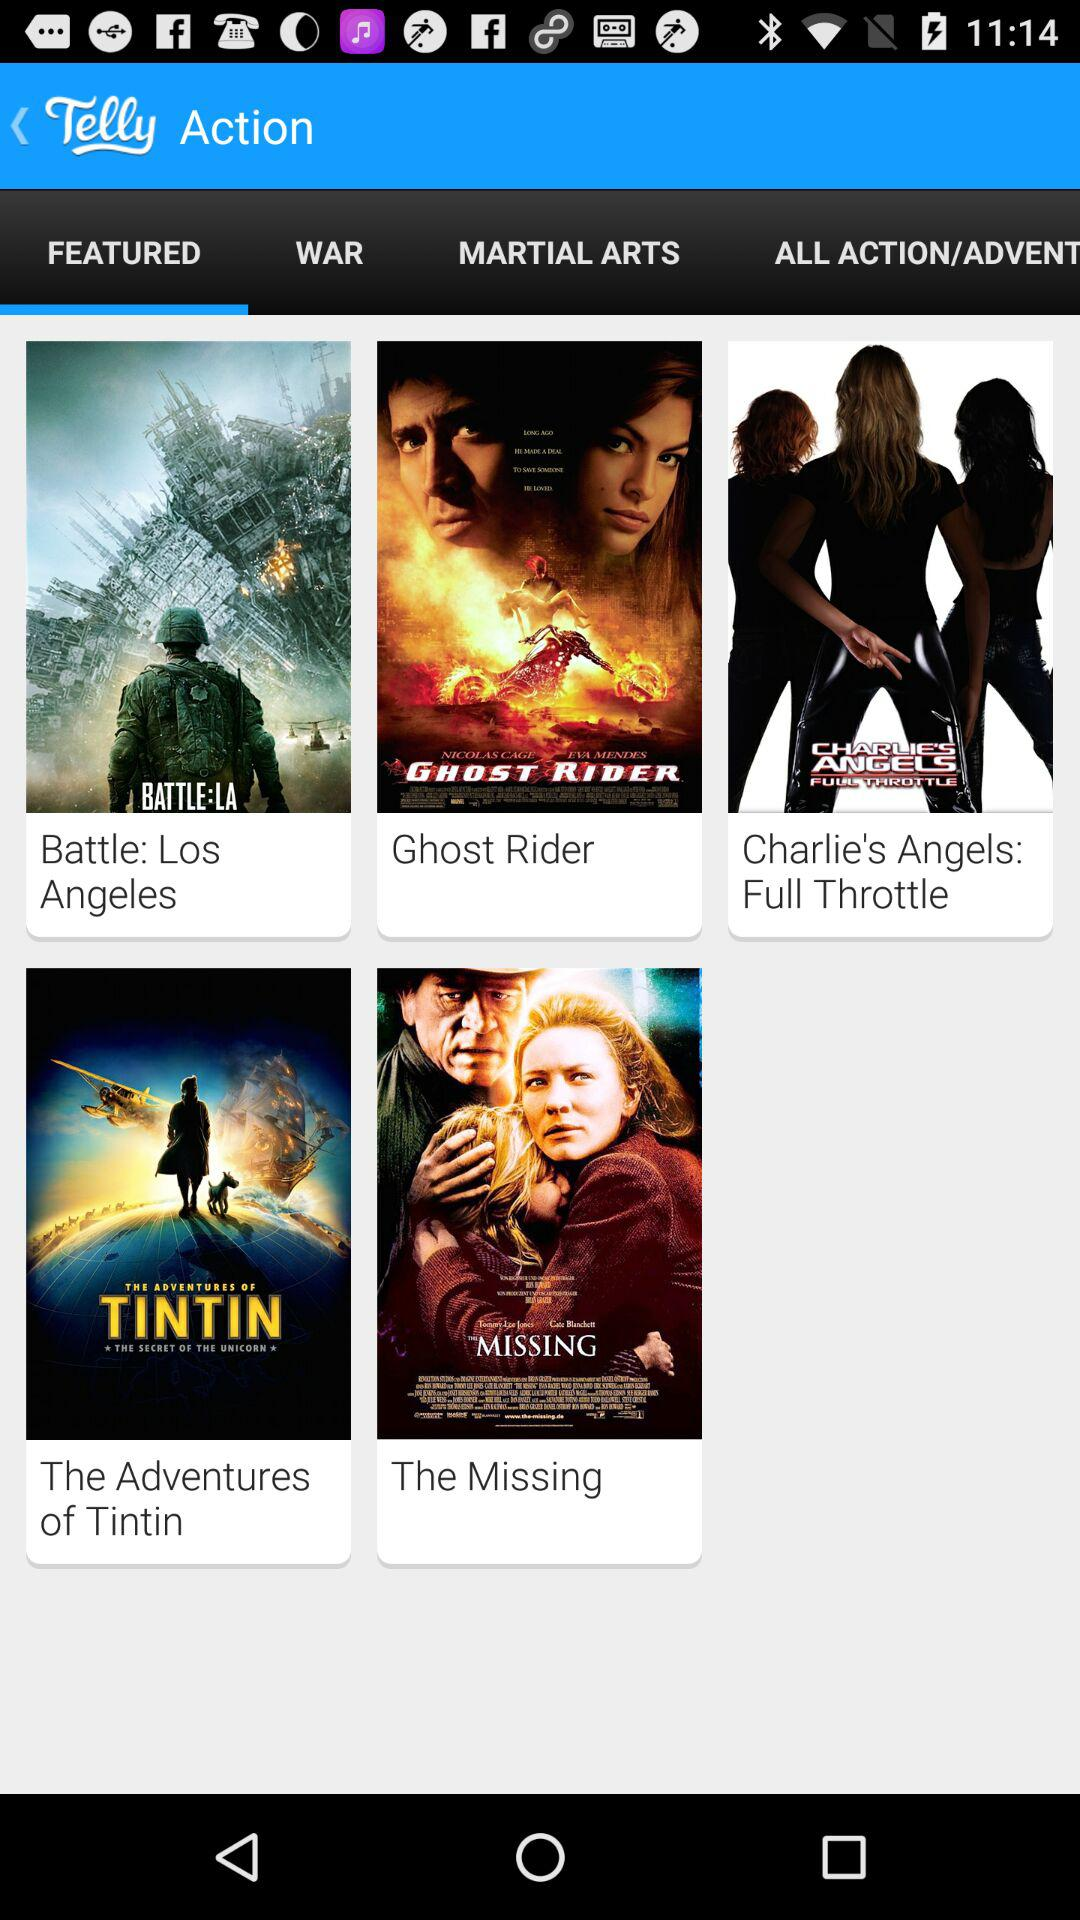Which movies are listed in "WAR"?
When the provided information is insufficient, respond with <no answer>. <no answer> 